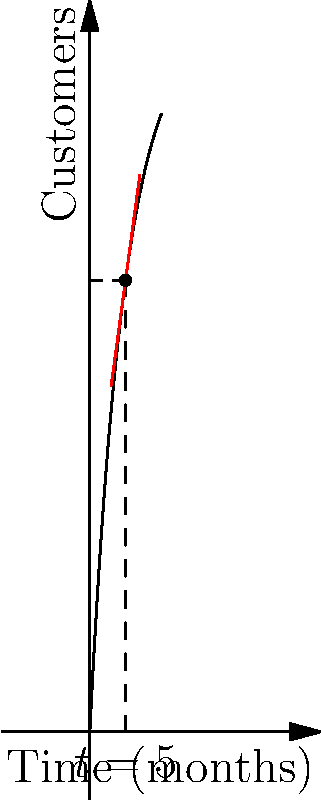As an e-commerce entrepreneur, you're tracking customer acquisition over time. The graph shows the number of customers $f(t)$ as a function of time $t$ in months. At $t=5$ months, you want to determine the rate of customer acquisition. Using the tangent line method:

1) What is the approximate rate of customer acquisition (customers/month) at $t=5$ months?
2) If this rate continues, how many new customers would you expect to gain in the next 2 months? Let's approach this step-by-step:

1) The rate of customer acquisition at $t=5$ is given by the slope of the tangent line at that point.

2) The equation for customer growth appears to be of the form:
   $$f(t) = A(1-e^{-kt})$$
   where $A$ is the maximum number of customers and $k$ is the growth rate.

3) To find the slope at $t=5$, we need to differentiate $f(t)$:
   $$f'(t) = Ake^{-kt}$$

4) At $t=5$, the slope (rate of acquisition) is:
   $$f'(5) = Ake^{-5k}$$

5) From the graph, we can estimate $A \approx 100$ and $k \approx 0.2$:
   $$f'(5) \approx 100 \cdot 0.2 \cdot e^{-5 \cdot 0.2} \approx 7.36$$

6) Therefore, the rate of customer acquisition at $t=5$ is approximately 7.36 customers/month.

7) If this rate continues for 2 months, the number of new customers would be:
   $$7.36 \text{ customers/month} \cdot 2 \text{ months} \approx 14.72 \text{ customers}$$
Answer: 1) 7.36 customers/month
2) 14.72 customers 